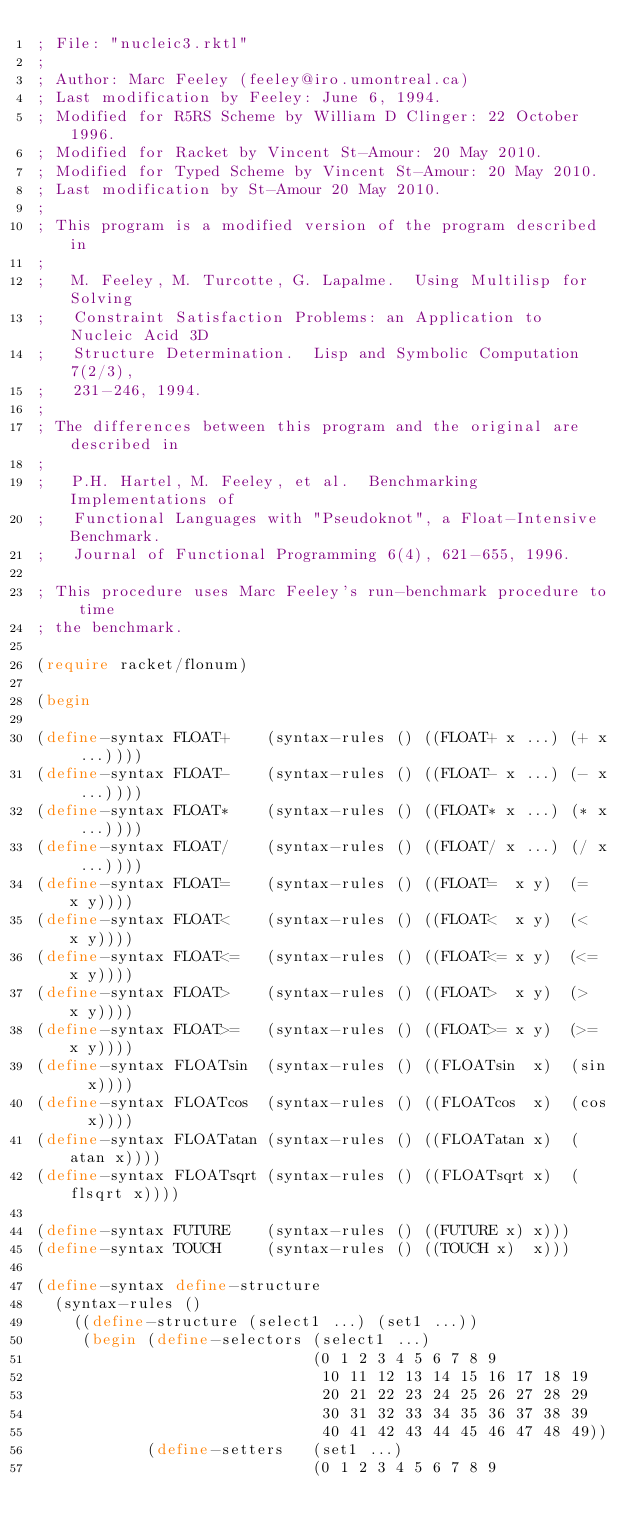<code> <loc_0><loc_0><loc_500><loc_500><_Racket_>; File: "nucleic3.rktl"
;
; Author: Marc Feeley (feeley@iro.umontreal.ca)
; Last modification by Feeley: June 6, 1994.
; Modified for R5RS Scheme by William D Clinger: 22 October 1996.
; Modified for Racket by Vincent St-Amour: 20 May 2010.
; Modified for Typed Scheme by Vincent St-Amour: 20 May 2010.
; Last modification by St-Amour 20 May 2010.
;
; This program is a modified version of the program described in
;
;   M. Feeley, M. Turcotte, G. Lapalme.  Using Multilisp for Solving
;   Constraint Satisfaction Problems: an Application to Nucleic Acid 3D
;   Structure Determination.  Lisp and Symbolic Computation 7(2/3),
;   231-246, 1994.
;
; The differences between this program and the original are described in
;
;   P.H. Hartel, M. Feeley, et al.  Benchmarking Implementations of
;   Functional Languages with "Pseudoknot", a Float-Intensive Benchmark.
;   Journal of Functional Programming 6(4), 621-655, 1996.

; This procedure uses Marc Feeley's run-benchmark procedure to time
; the benchmark.

(require racket/flonum)

(begin

(define-syntax FLOAT+    (syntax-rules () ((FLOAT+ x ...) (+ x ...))))
(define-syntax FLOAT-    (syntax-rules () ((FLOAT- x ...) (- x ...))))
(define-syntax FLOAT*    (syntax-rules () ((FLOAT* x ...) (* x ...))))
(define-syntax FLOAT/    (syntax-rules () ((FLOAT/ x ...) (/ x ...))))
(define-syntax FLOAT=    (syntax-rules () ((FLOAT=  x y)  (=  x y))))
(define-syntax FLOAT<    (syntax-rules () ((FLOAT<  x y)  (<  x y))))
(define-syntax FLOAT<=   (syntax-rules () ((FLOAT<= x y)  (<= x y))))
(define-syntax FLOAT>    (syntax-rules () ((FLOAT>  x y)  (>  x y))))
(define-syntax FLOAT>=   (syntax-rules () ((FLOAT>= x y)  (>= x y))))
(define-syntax FLOATsin  (syntax-rules () ((FLOATsin  x)  (sin  x))))
(define-syntax FLOATcos  (syntax-rules () ((FLOATcos  x)  (cos  x))))
(define-syntax FLOATatan (syntax-rules () ((FLOATatan x)  (atan x))))
(define-syntax FLOATsqrt (syntax-rules () ((FLOATsqrt x)  (flsqrt x))))

(define-syntax FUTURE    (syntax-rules () ((FUTURE x) x)))
(define-syntax TOUCH     (syntax-rules () ((TOUCH x)  x)))

(define-syntax define-structure
  (syntax-rules ()
    ((define-structure (select1 ...) (set1 ...))
     (begin (define-selectors (select1 ...)
                              (0 1 2 3 4 5 6 7 8 9
                               10 11 12 13 14 15 16 17 18 19
                               20 21 22 23 24 25 26 27 28 29
                               30 31 32 33 34 35 36 37 38 39
                               40 41 42 43 44 45 46 47 48 49))
            (define-setters   (set1 ...)
                              (0 1 2 3 4 5 6 7 8 9</code> 